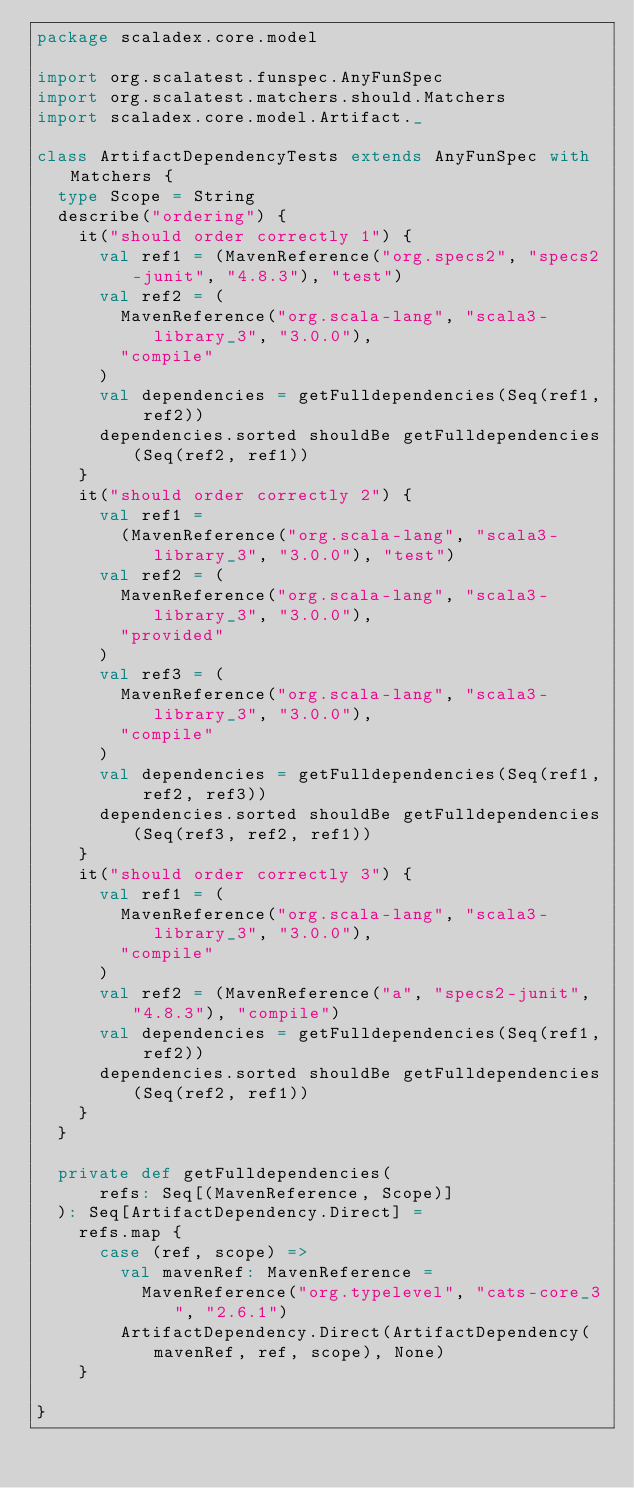Convert code to text. <code><loc_0><loc_0><loc_500><loc_500><_Scala_>package scaladex.core.model

import org.scalatest.funspec.AnyFunSpec
import org.scalatest.matchers.should.Matchers
import scaladex.core.model.Artifact._

class ArtifactDependencyTests extends AnyFunSpec with Matchers {
  type Scope = String
  describe("ordering") {
    it("should order correctly 1") {
      val ref1 = (MavenReference("org.specs2", "specs2-junit", "4.8.3"), "test")
      val ref2 = (
        MavenReference("org.scala-lang", "scala3-library_3", "3.0.0"),
        "compile"
      )
      val dependencies = getFulldependencies(Seq(ref1, ref2))
      dependencies.sorted shouldBe getFulldependencies(Seq(ref2, ref1))
    }
    it("should order correctly 2") {
      val ref1 =
        (MavenReference("org.scala-lang", "scala3-library_3", "3.0.0"), "test")
      val ref2 = (
        MavenReference("org.scala-lang", "scala3-library_3", "3.0.0"),
        "provided"
      )
      val ref3 = (
        MavenReference("org.scala-lang", "scala3-library_3", "3.0.0"),
        "compile"
      )
      val dependencies = getFulldependencies(Seq(ref1, ref2, ref3))
      dependencies.sorted shouldBe getFulldependencies(Seq(ref3, ref2, ref1))
    }
    it("should order correctly 3") {
      val ref1 = (
        MavenReference("org.scala-lang", "scala3-library_3", "3.0.0"),
        "compile"
      )
      val ref2 = (MavenReference("a", "specs2-junit", "4.8.3"), "compile")
      val dependencies = getFulldependencies(Seq(ref1, ref2))
      dependencies.sorted shouldBe getFulldependencies(Seq(ref2, ref1))
    }
  }

  private def getFulldependencies(
      refs: Seq[(MavenReference, Scope)]
  ): Seq[ArtifactDependency.Direct] =
    refs.map {
      case (ref, scope) =>
        val mavenRef: MavenReference =
          MavenReference("org.typelevel", "cats-core_3", "2.6.1")
        ArtifactDependency.Direct(ArtifactDependency(mavenRef, ref, scope), None)
    }

}
</code> 